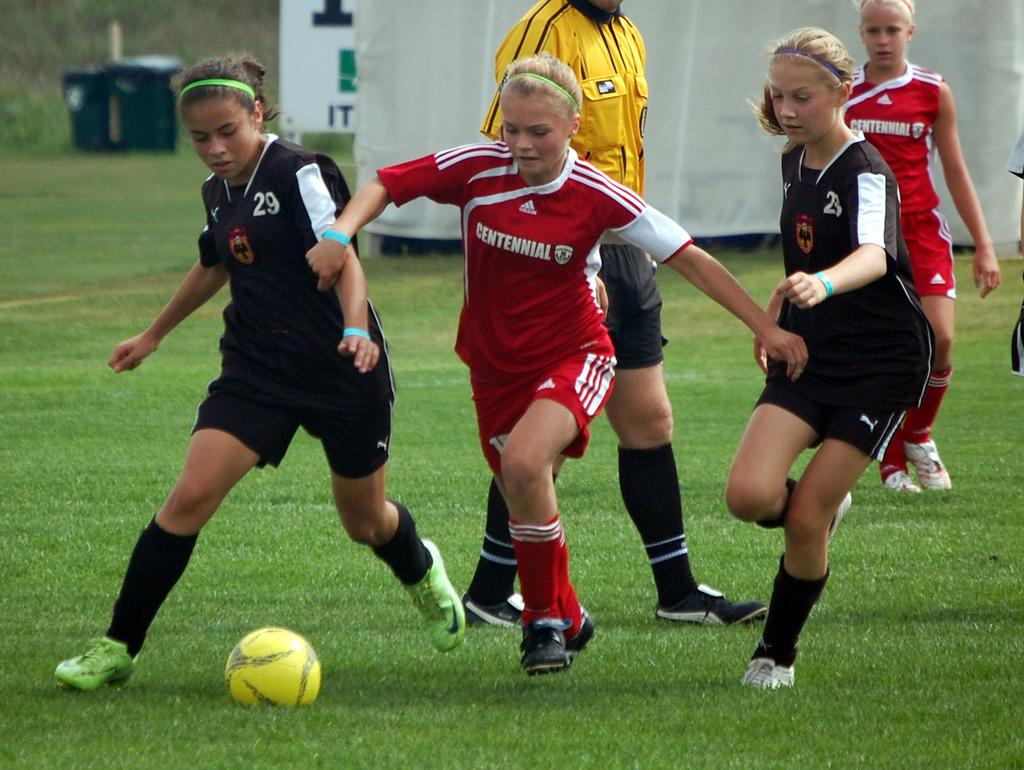Provide a one-sentence caption for the provided image. Players from one soccer team wear Adidas uniforms, while the others wear Puma uniforms. 